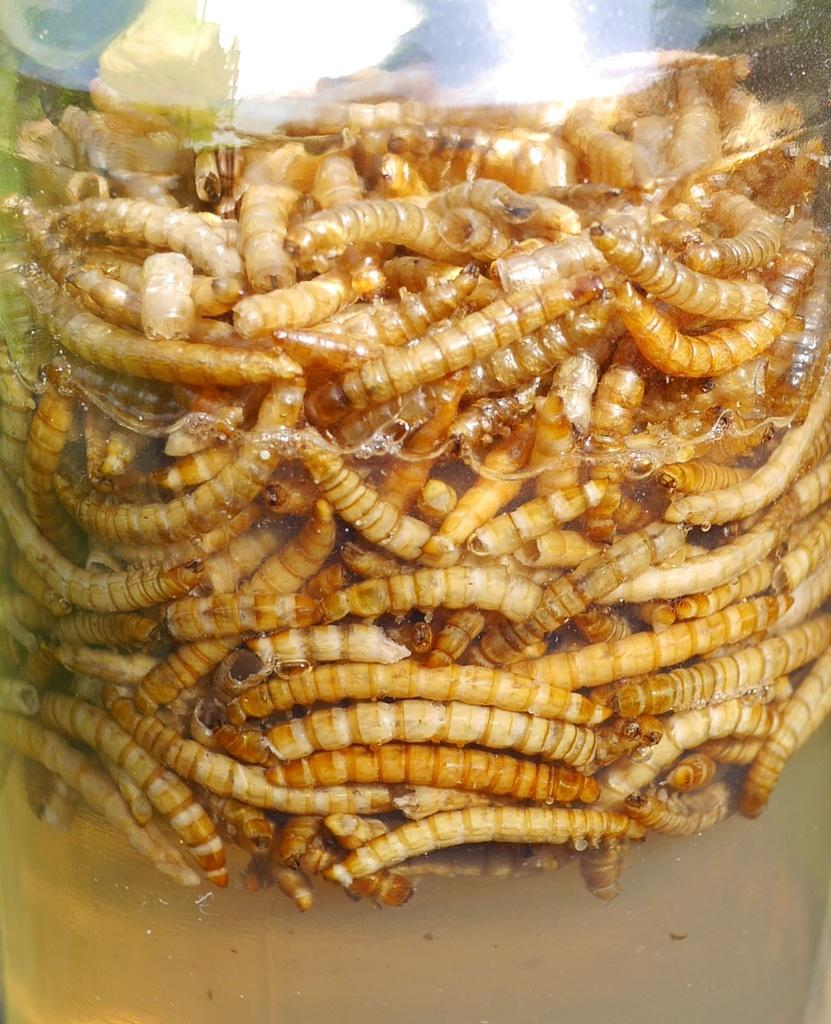What type of living organisms can be seen in the picture? Insects can be seen in the picture. What is the glass item containing in the picture? There is a glass item containing a type of liquid in the picture. What type of meat is being prepared by the insects in the picture? There is no meat present in the image, and the insects are not preparing any food. 